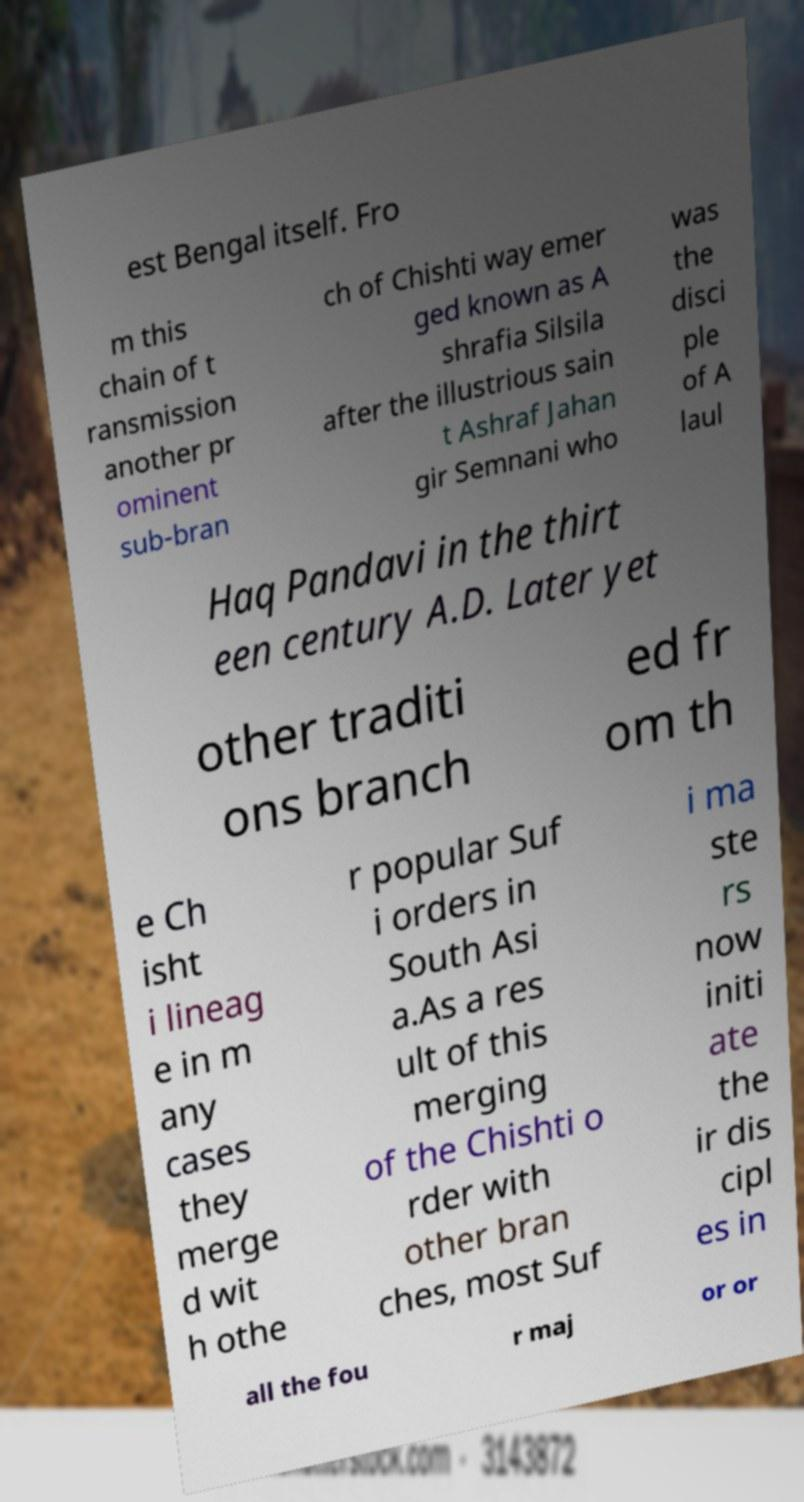Could you extract and type out the text from this image? est Bengal itself. Fro m this chain of t ransmission another pr ominent sub-bran ch of Chishti way emer ged known as A shrafia Silsila after the illustrious sain t Ashraf Jahan gir Semnani who was the disci ple of A laul Haq Pandavi in the thirt een century A.D. Later yet other traditi ons branch ed fr om th e Ch isht i lineag e in m any cases they merge d wit h othe r popular Suf i orders in South Asi a.As a res ult of this merging of the Chishti o rder with other bran ches, most Suf i ma ste rs now initi ate the ir dis cipl es in all the fou r maj or or 